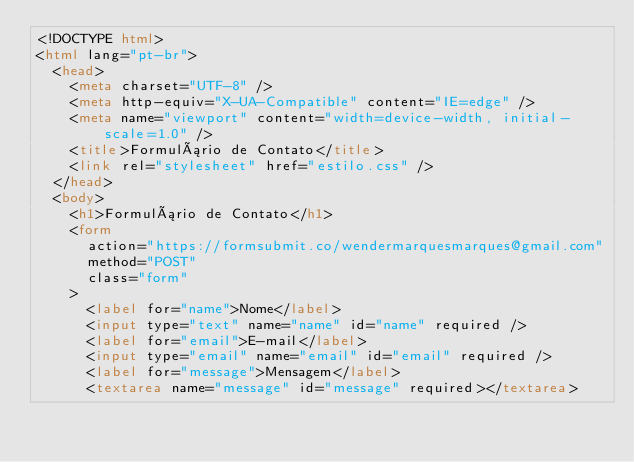<code> <loc_0><loc_0><loc_500><loc_500><_HTML_><!DOCTYPE html>
<html lang="pt-br">
  <head>
    <meta charset="UTF-8" />
    <meta http-equiv="X-UA-Compatible" content="IE=edge" />
    <meta name="viewport" content="width=device-width, initial-scale=1.0" />
    <title>Formulário de Contato</title>
    <link rel="stylesheet" href="estilo.css" />
  </head>
  <body>
    <h1>Formulário de Contato</h1>
    <form
      action="https://formsubmit.co/wendermarquesmarques@gmail.com"
      method="POST"
      class="form"
    >
      <label for="name">Nome</label>
      <input type="text" name="name" id="name" required />
      <label for="email">E-mail</label>
      <input type="email" name="email" id="email" required />
      <label for="message">Mensagem</label>
      <textarea name="message" id="message" required></textarea></code> 